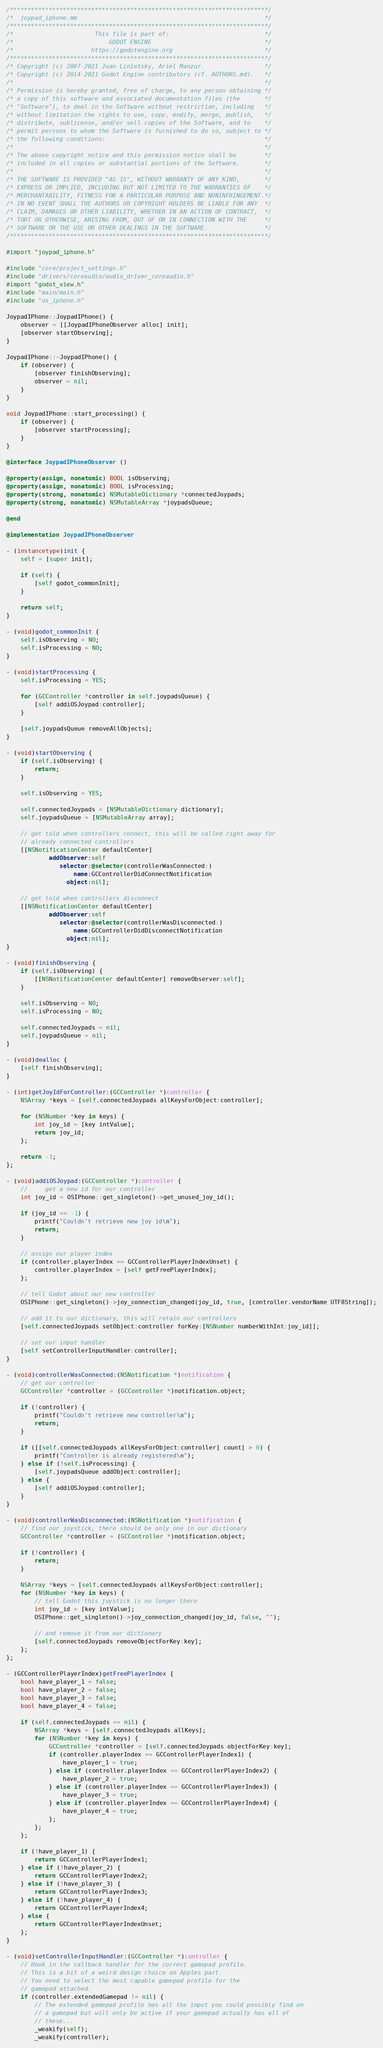<code> <loc_0><loc_0><loc_500><loc_500><_ObjectiveC_>/*************************************************************************/
/*  joypad_iphone.mm                                                     */
/*************************************************************************/
/*                       This file is part of:                           */
/*                           GODOT ENGINE                                */
/*                      https://godotengine.org                          */
/*************************************************************************/
/* Copyright (c) 2007-2021 Juan Linietsky, Ariel Manzur.                 */
/* Copyright (c) 2014-2021 Godot Engine contributors (cf. AUTHORS.md).   */
/*                                                                       */
/* Permission is hereby granted, free of charge, to any person obtaining */
/* a copy of this software and associated documentation files (the       */
/* "Software"), to deal in the Software without restriction, including   */
/* without limitation the rights to use, copy, modify, merge, publish,   */
/* distribute, sublicense, and/or sell copies of the Software, and to    */
/* permit persons to whom the Software is furnished to do so, subject to */
/* the following conditions:                                             */
/*                                                                       */
/* The above copyright notice and this permission notice shall be        */
/* included in all copies or substantial portions of the Software.       */
/*                                                                       */
/* THE SOFTWARE IS PROVIDED "AS IS", WITHOUT WARRANTY OF ANY KIND,       */
/* EXPRESS OR IMPLIED, INCLUDING BUT NOT LIMITED TO THE WARRANTIES OF    */
/* MERCHANTABILITY, FITNESS FOR A PARTICULAR PURPOSE AND NONINFRINGEMENT.*/
/* IN NO EVENT SHALL THE AUTHORS OR COPYRIGHT HOLDERS BE LIABLE FOR ANY  */
/* CLAIM, DAMAGES OR OTHER LIABILITY, WHETHER IN AN ACTION OF CONTRACT,  */
/* TORT OR OTHERWISE, ARISING FROM, OUT OF OR IN CONNECTION WITH THE     */
/* SOFTWARE OR THE USE OR OTHER DEALINGS IN THE SOFTWARE.                */
/*************************************************************************/

#import "joypad_iphone.h"

#include "core/project_settings.h"
#include "drivers/coreaudio/audio_driver_coreaudio.h"
#import "godot_view.h"
#include "main/main.h"
#include "os_iphone.h"

JoypadIPhone::JoypadIPhone() {
	observer = [[JoypadIPhoneObserver alloc] init];
	[observer startObserving];
}

JoypadIPhone::~JoypadIPhone() {
	if (observer) {
		[observer finishObserving];
		observer = nil;
	}
}

void JoypadIPhone::start_processing() {
	if (observer) {
		[observer startProcessing];
	}
}

@interface JoypadIPhoneObserver ()

@property(assign, nonatomic) BOOL isObserving;
@property(assign, nonatomic) BOOL isProcessing;
@property(strong, nonatomic) NSMutableDictionary *connectedJoypads;
@property(strong, nonatomic) NSMutableArray *joypadsQueue;

@end

@implementation JoypadIPhoneObserver

- (instancetype)init {
	self = [super init];

	if (self) {
		[self godot_commonInit];
	}

	return self;
}

- (void)godot_commonInit {
	self.isObserving = NO;
	self.isProcessing = NO;
}

- (void)startProcessing {
	self.isProcessing = YES;

	for (GCController *controller in self.joypadsQueue) {
		[self addiOSJoypad:controller];
	}

	[self.joypadsQueue removeAllObjects];
}

- (void)startObserving {
	if (self.isObserving) {
		return;
	}

	self.isObserving = YES;

	self.connectedJoypads = [NSMutableDictionary dictionary];
	self.joypadsQueue = [NSMutableArray array];

	// get told when controllers connect, this will be called right away for
	// already connected controllers
	[[NSNotificationCenter defaultCenter]
			addObserver:self
			   selector:@selector(controllerWasConnected:)
				   name:GCControllerDidConnectNotification
				 object:nil];

	// get told when controllers disconnect
	[[NSNotificationCenter defaultCenter]
			addObserver:self
			   selector:@selector(controllerWasDisconnected:)
				   name:GCControllerDidDisconnectNotification
				 object:nil];
}

- (void)finishObserving {
	if (self.isObserving) {
		[[NSNotificationCenter defaultCenter] removeObserver:self];
	}

	self.isObserving = NO;
	self.isProcessing = NO;

	self.connectedJoypads = nil;
	self.joypadsQueue = nil;
}

- (void)dealloc {
	[self finishObserving];
}

- (int)getJoyIdForController:(GCController *)controller {
	NSArray *keys = [self.connectedJoypads allKeysForObject:controller];

	for (NSNumber *key in keys) {
		int joy_id = [key intValue];
		return joy_id;
	};

	return -1;
};

- (void)addiOSJoypad:(GCController *)controller {
	//     get a new id for our controller
	int joy_id = OSIPhone::get_singleton()->get_unused_joy_id();

	if (joy_id == -1) {
		printf("Couldn't retrieve new joy id\n");
		return;
	}

	// assign our player index
	if (controller.playerIndex == GCControllerPlayerIndexUnset) {
		controller.playerIndex = [self getFreePlayerIndex];
	};

	// tell Godot about our new controller
	OSIPhone::get_singleton()->joy_connection_changed(joy_id, true, [controller.vendorName UTF8String]);

	// add it to our dictionary, this will retain our controllers
	[self.connectedJoypads setObject:controller forKey:[NSNumber numberWithInt:joy_id]];

	// set our input handler
	[self setControllerInputHandler:controller];
}

- (void)controllerWasConnected:(NSNotification *)notification {
	// get our controller
	GCController *controller = (GCController *)notification.object;

	if (!controller) {
		printf("Couldn't retrieve new controller\n");
		return;
	}

	if ([[self.connectedJoypads allKeysForObject:controller] count] > 0) {
		printf("Controller is already registered\n");
	} else if (!self.isProcessing) {
		[self.joypadsQueue addObject:controller];
	} else {
		[self addiOSJoypad:controller];
	}
}

- (void)controllerWasDisconnected:(NSNotification *)notification {
	// find our joystick, there should be only one in our dictionary
	GCController *controller = (GCController *)notification.object;

	if (!controller) {
		return;
	}

	NSArray *keys = [self.connectedJoypads allKeysForObject:controller];
	for (NSNumber *key in keys) {
		// tell Godot this joystick is no longer there
		int joy_id = [key intValue];
		OSIPhone::get_singleton()->joy_connection_changed(joy_id, false, "");

		// and remove it from our dictionary
		[self.connectedJoypads removeObjectForKey:key];
	};
};

- (GCControllerPlayerIndex)getFreePlayerIndex {
	bool have_player_1 = false;
	bool have_player_2 = false;
	bool have_player_3 = false;
	bool have_player_4 = false;

	if (self.connectedJoypads == nil) {
		NSArray *keys = [self.connectedJoypads allKeys];
		for (NSNumber *key in keys) {
			GCController *controller = [self.connectedJoypads objectForKey:key];
			if (controller.playerIndex == GCControllerPlayerIndex1) {
				have_player_1 = true;
			} else if (controller.playerIndex == GCControllerPlayerIndex2) {
				have_player_2 = true;
			} else if (controller.playerIndex == GCControllerPlayerIndex3) {
				have_player_3 = true;
			} else if (controller.playerIndex == GCControllerPlayerIndex4) {
				have_player_4 = true;
			};
		};
	};

	if (!have_player_1) {
		return GCControllerPlayerIndex1;
	} else if (!have_player_2) {
		return GCControllerPlayerIndex2;
	} else if (!have_player_3) {
		return GCControllerPlayerIndex3;
	} else if (!have_player_4) {
		return GCControllerPlayerIndex4;
	} else {
		return GCControllerPlayerIndexUnset;
	};
}

- (void)setControllerInputHandler:(GCController *)controller {
	// Hook in the callback handler for the correct gamepad profile.
	// This is a bit of a weird design choice on Apples part.
	// You need to select the most capable gamepad profile for the
	// gamepad attached.
	if (controller.extendedGamepad != nil) {
		// The extended gamepad profile has all the input you could possibly find on
		// a gamepad but will only be active if your gamepad actually has all of
		// these...
		_weakify(self);
		_weakify(controller);
</code> 